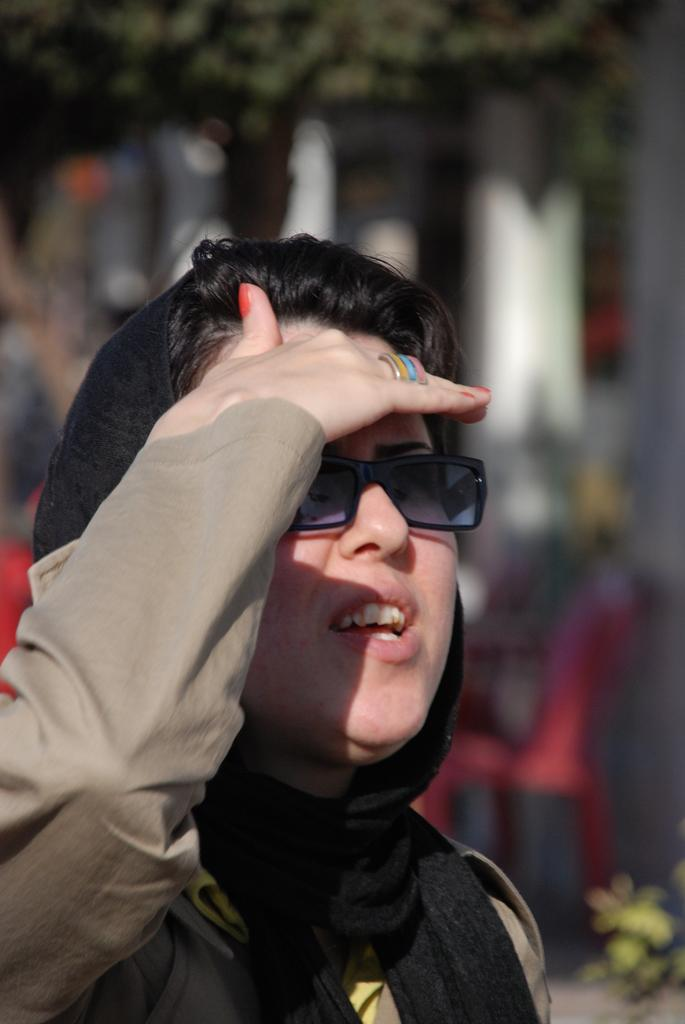Who is present in the image? There is a woman in the image. What is the woman wearing? The woman is wearing clothes, goggles, and a finger ring. What can be seen in the background of the image? The background of the image is blurred. What else is present in the image besides the woman? There is a tree in the image. What type of doll is sitting on the kettle in the image? There is no doll or kettle present in the image. What story is the woman telling in the image? The image does not depict the woman telling a story, so it cannot be determined from the image. 